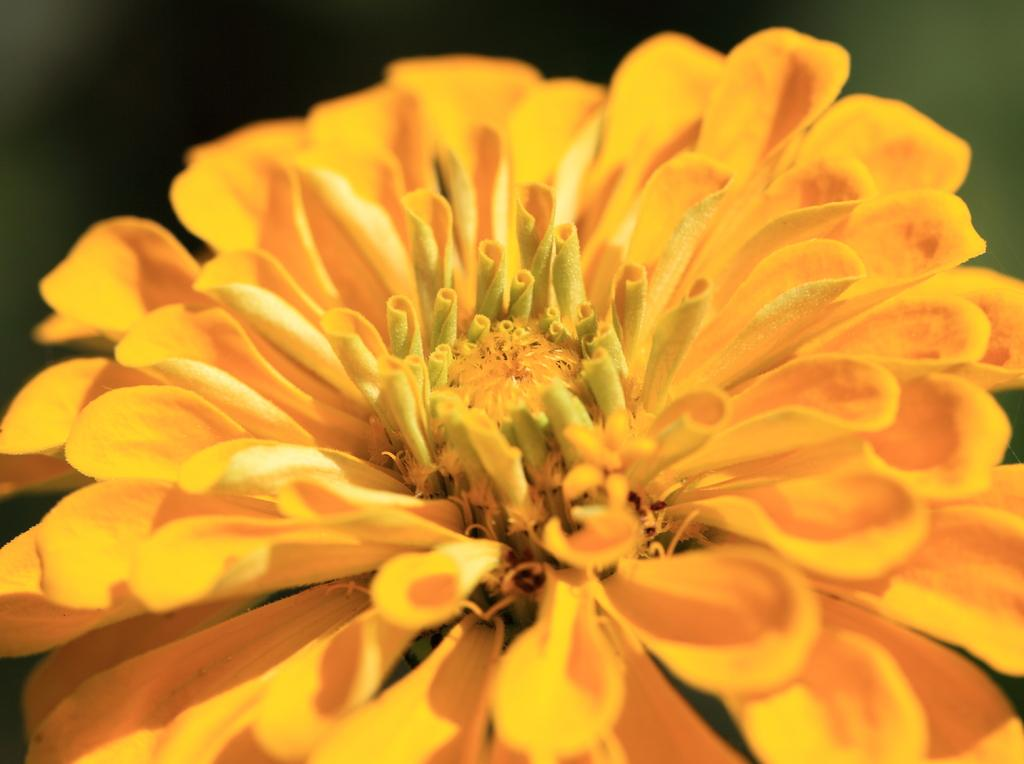What type of flower is present in the image? There is a yellow flower in the image. How does the yellow flower move around in the image? The yellow flower does not move around in the image; it is stationary. What type of chain is attached to the base of the yellow flower in the image? There is no chain or base mentioned in the provided facts, and therefore no such attachment can be observed. 